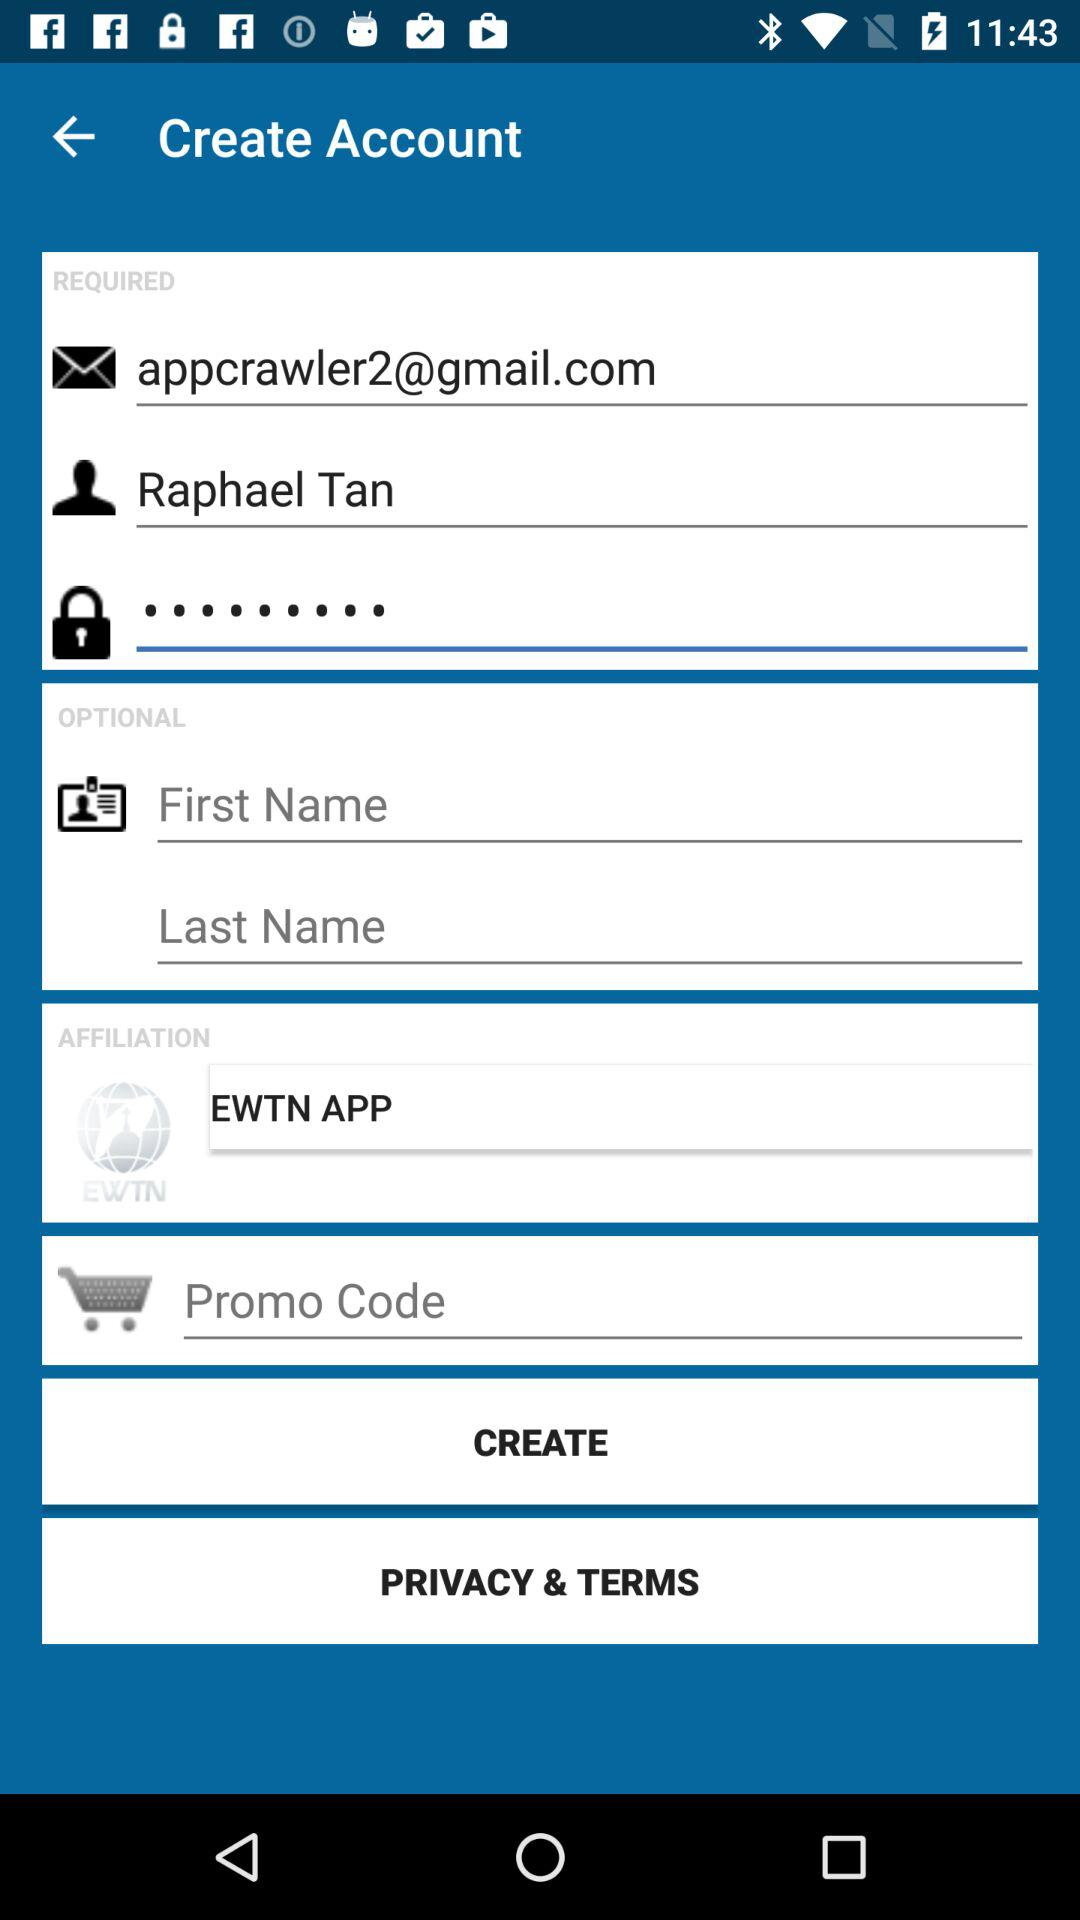What is the entered promo code?
When the provided information is insufficient, respond with <no answer>. <no answer> 